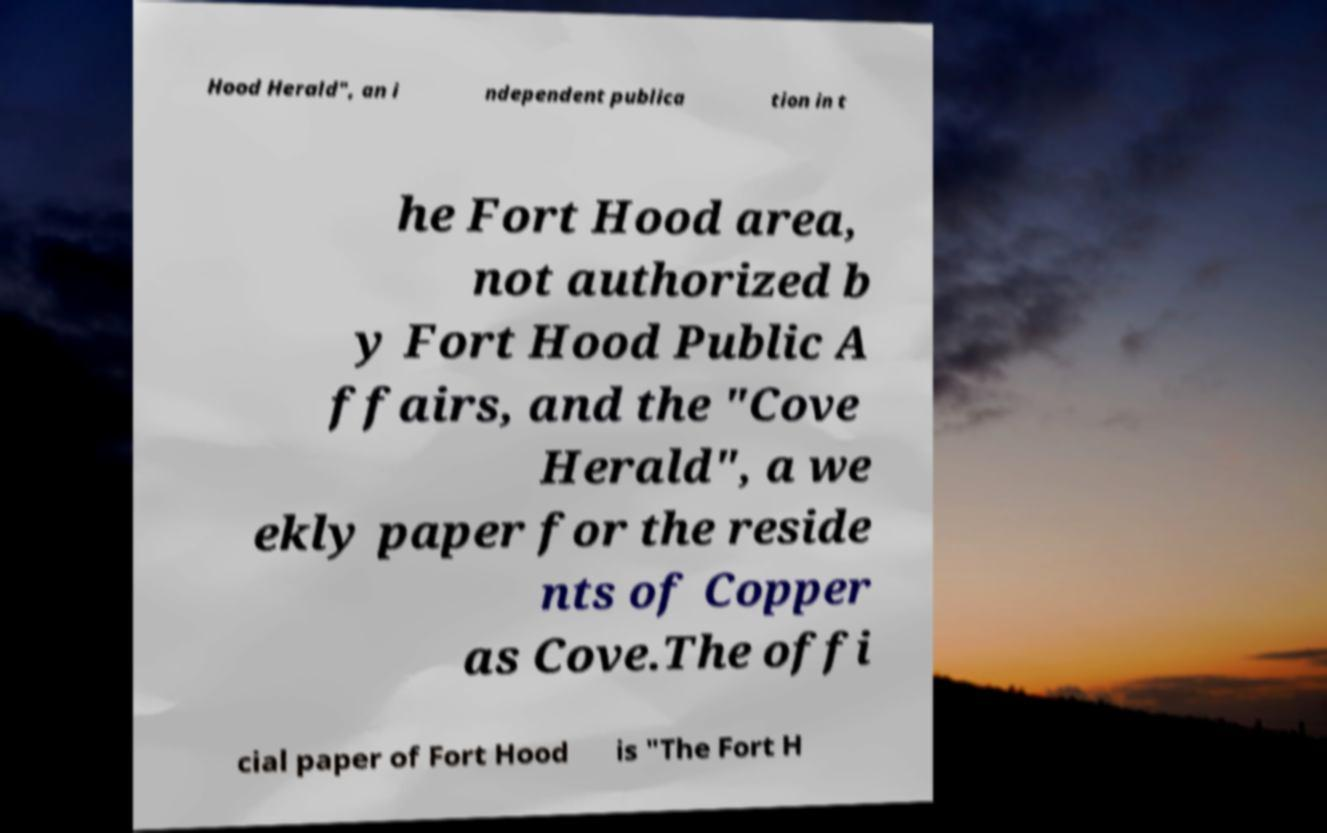There's text embedded in this image that I need extracted. Can you transcribe it verbatim? Hood Herald", an i ndependent publica tion in t he Fort Hood area, not authorized b y Fort Hood Public A ffairs, and the "Cove Herald", a we ekly paper for the reside nts of Copper as Cove.The offi cial paper of Fort Hood is "The Fort H 